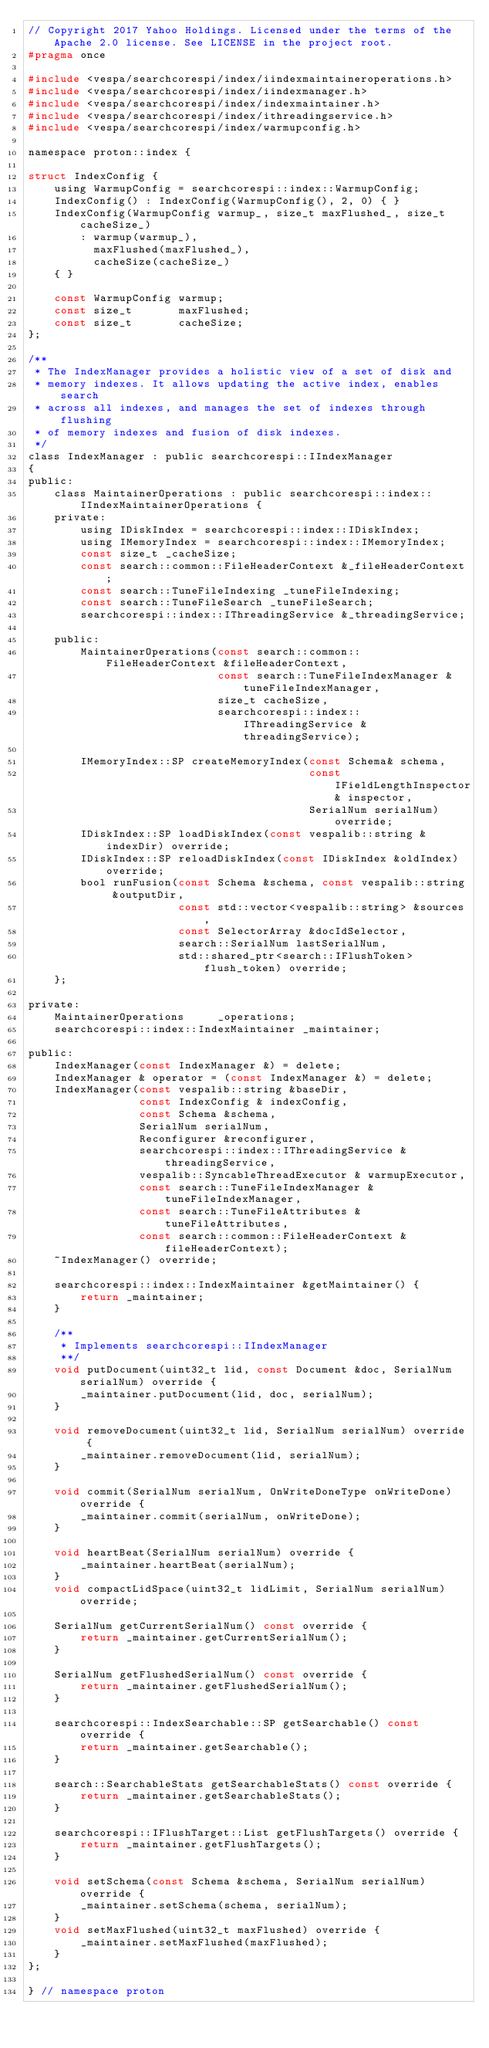Convert code to text. <code><loc_0><loc_0><loc_500><loc_500><_C_>// Copyright 2017 Yahoo Holdings. Licensed under the terms of the Apache 2.0 license. See LICENSE in the project root.
#pragma once

#include <vespa/searchcorespi/index/iindexmaintaineroperations.h>
#include <vespa/searchcorespi/index/iindexmanager.h>
#include <vespa/searchcorespi/index/indexmaintainer.h>
#include <vespa/searchcorespi/index/ithreadingservice.h>
#include <vespa/searchcorespi/index/warmupconfig.h>

namespace proton::index {

struct IndexConfig {
    using WarmupConfig = searchcorespi::index::WarmupConfig;
    IndexConfig() : IndexConfig(WarmupConfig(), 2, 0) { }
    IndexConfig(WarmupConfig warmup_, size_t maxFlushed_, size_t cacheSize_)
        : warmup(warmup_),
          maxFlushed(maxFlushed_),
          cacheSize(cacheSize_)
    { }

    const WarmupConfig warmup;
    const size_t       maxFlushed;
    const size_t       cacheSize;
};

/**
 * The IndexManager provides a holistic view of a set of disk and
 * memory indexes. It allows updating the active index, enables search
 * across all indexes, and manages the set of indexes through flushing
 * of memory indexes and fusion of disk indexes.
 */
class IndexManager : public searchcorespi::IIndexManager
{
public:
    class MaintainerOperations : public searchcorespi::index::IIndexMaintainerOperations {
    private:
        using IDiskIndex = searchcorespi::index::IDiskIndex;
        using IMemoryIndex = searchcorespi::index::IMemoryIndex;
        const size_t _cacheSize;
        const search::common::FileHeaderContext &_fileHeaderContext;
        const search::TuneFileIndexing _tuneFileIndexing;
        const search::TuneFileSearch _tuneFileSearch;
        searchcorespi::index::IThreadingService &_threadingService;

    public:
        MaintainerOperations(const search::common::FileHeaderContext &fileHeaderContext,
                             const search::TuneFileIndexManager &tuneFileIndexManager,
                             size_t cacheSize,
                             searchcorespi::index::IThreadingService &threadingService);

        IMemoryIndex::SP createMemoryIndex(const Schema& schema,
                                           const IFieldLengthInspector& inspector,
                                           SerialNum serialNum) override;
        IDiskIndex::SP loadDiskIndex(const vespalib::string &indexDir) override;
        IDiskIndex::SP reloadDiskIndex(const IDiskIndex &oldIndex) override;
        bool runFusion(const Schema &schema, const vespalib::string &outputDir,
                       const std::vector<vespalib::string> &sources,
                       const SelectorArray &docIdSelector,
                       search::SerialNum lastSerialNum,
                       std::shared_ptr<search::IFlushToken> flush_token) override;
    };

private:
    MaintainerOperations     _operations;
    searchcorespi::index::IndexMaintainer _maintainer;

public:
    IndexManager(const IndexManager &) = delete;
    IndexManager & operator = (const IndexManager &) = delete;
    IndexManager(const vespalib::string &baseDir,
                 const IndexConfig & indexConfig,
                 const Schema &schema,
                 SerialNum serialNum,
                 Reconfigurer &reconfigurer,
                 searchcorespi::index::IThreadingService &threadingService,
                 vespalib::SyncableThreadExecutor & warmupExecutor,
                 const search::TuneFileIndexManager &tuneFileIndexManager,
                 const search::TuneFileAttributes &tuneFileAttributes,
                 const search::common::FileHeaderContext &fileHeaderContext);
    ~IndexManager() override;

    searchcorespi::index::IndexMaintainer &getMaintainer() {
        return _maintainer;
    }

    /**
     * Implements searchcorespi::IIndexManager
     **/
    void putDocument(uint32_t lid, const Document &doc, SerialNum serialNum) override {
        _maintainer.putDocument(lid, doc, serialNum);
    }

    void removeDocument(uint32_t lid, SerialNum serialNum) override {
        _maintainer.removeDocument(lid, serialNum);
    }

    void commit(SerialNum serialNum, OnWriteDoneType onWriteDone) override {
        _maintainer.commit(serialNum, onWriteDone);
    }

    void heartBeat(SerialNum serialNum) override {
        _maintainer.heartBeat(serialNum);
    }
    void compactLidSpace(uint32_t lidLimit, SerialNum serialNum) override;

    SerialNum getCurrentSerialNum() const override {
        return _maintainer.getCurrentSerialNum();
    }

    SerialNum getFlushedSerialNum() const override {
        return _maintainer.getFlushedSerialNum();
    }

    searchcorespi::IndexSearchable::SP getSearchable() const override {
        return _maintainer.getSearchable();
    }

    search::SearchableStats getSearchableStats() const override {
        return _maintainer.getSearchableStats();
    }

    searchcorespi::IFlushTarget::List getFlushTargets() override {
        return _maintainer.getFlushTargets();
    }

    void setSchema(const Schema &schema, SerialNum serialNum) override {
        _maintainer.setSchema(schema, serialNum);
    }
    void setMaxFlushed(uint32_t maxFlushed) override {
        _maintainer.setMaxFlushed(maxFlushed);
    }
};

} // namespace proton

</code> 